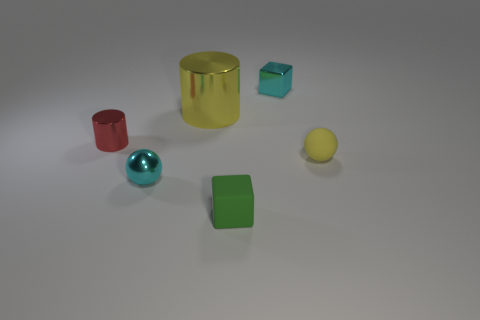Add 3 cyan shiny cylinders. How many objects exist? 9 Subtract all balls. How many objects are left? 4 Subtract 0 yellow blocks. How many objects are left? 6 Subtract all yellow objects. Subtract all small rubber spheres. How many objects are left? 3 Add 5 tiny yellow matte balls. How many tiny yellow matte balls are left? 6 Add 5 cylinders. How many cylinders exist? 7 